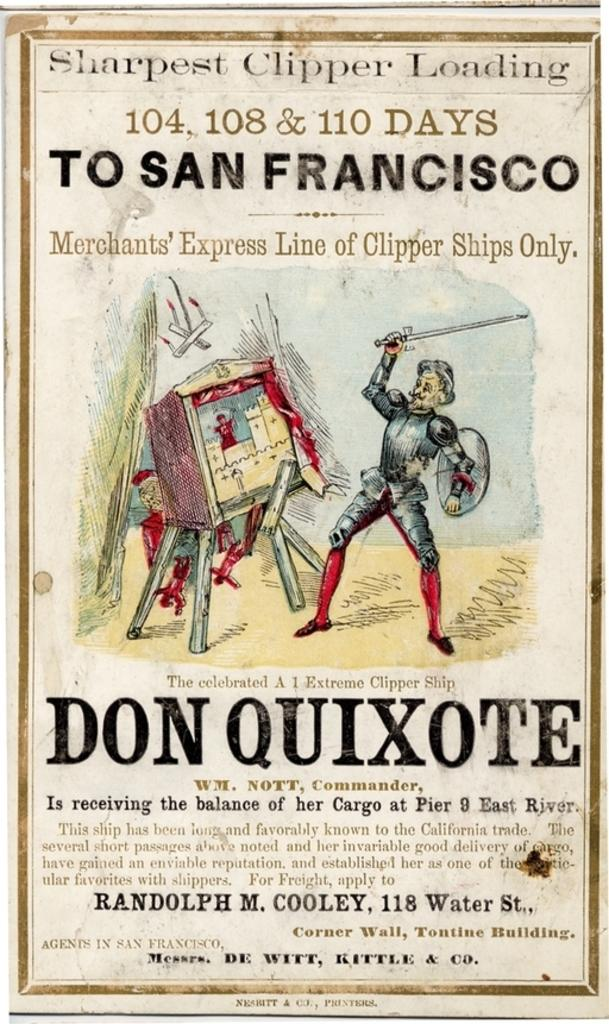<image>
Relay a brief, clear account of the picture shown. A poster has a man in armor holding a small sword and it says don quixote under it 